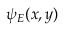Convert formula to latex. <formula><loc_0><loc_0><loc_500><loc_500>\psi _ { E } ( x , y )</formula> 